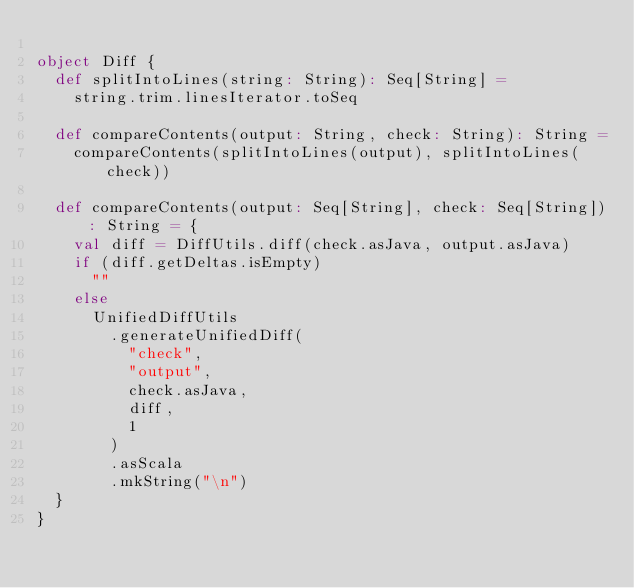<code> <loc_0><loc_0><loc_500><loc_500><_Scala_>
object Diff {
  def splitIntoLines(string: String): Seq[String] =
    string.trim.linesIterator.toSeq

  def compareContents(output: String, check: String): String =
    compareContents(splitIntoLines(output), splitIntoLines(check))

  def compareContents(output: Seq[String], check: Seq[String]): String = {
    val diff = DiffUtils.diff(check.asJava, output.asJava)
    if (diff.getDeltas.isEmpty)
      ""
    else
      UnifiedDiffUtils
        .generateUnifiedDiff(
          "check",
          "output",
          check.asJava,
          diff,
          1
        )
        .asScala
        .mkString("\n")
  }
}
</code> 